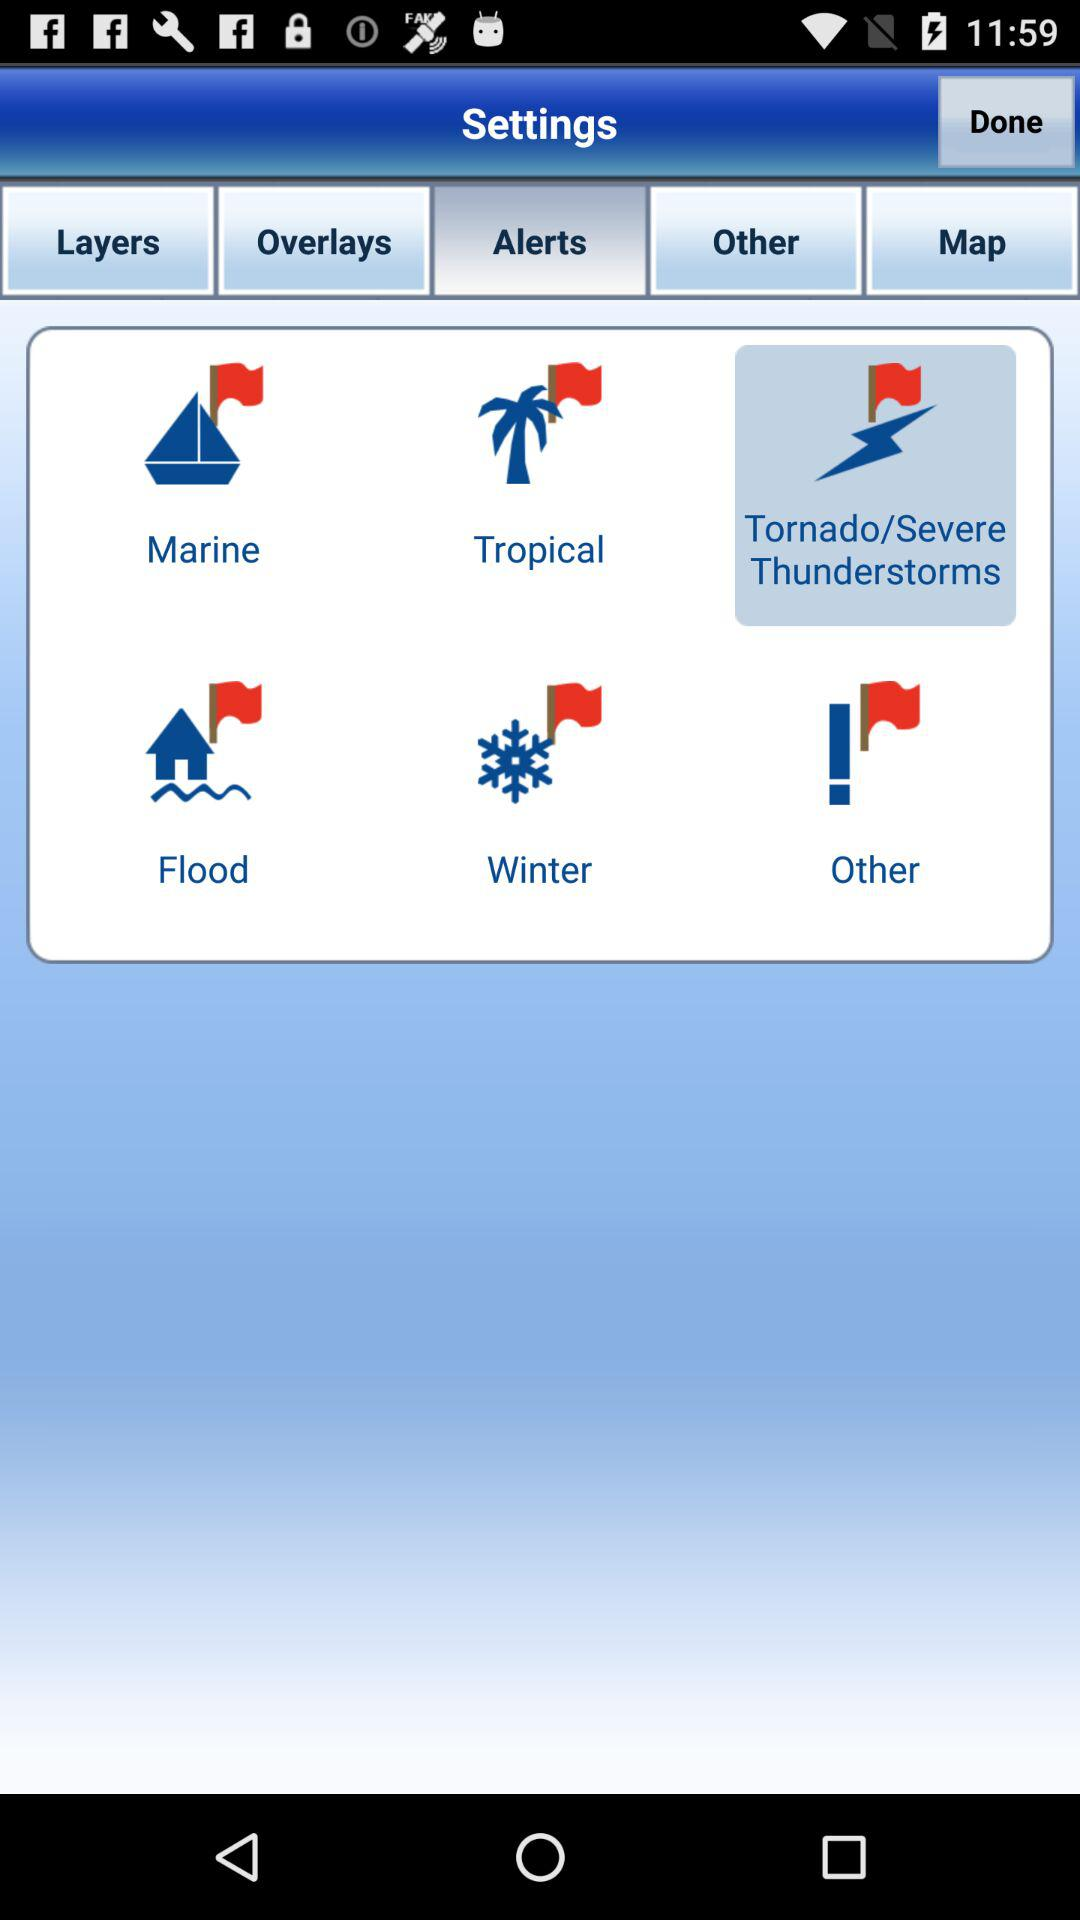Which tab has been selected? The selected tab is "Alerts". 